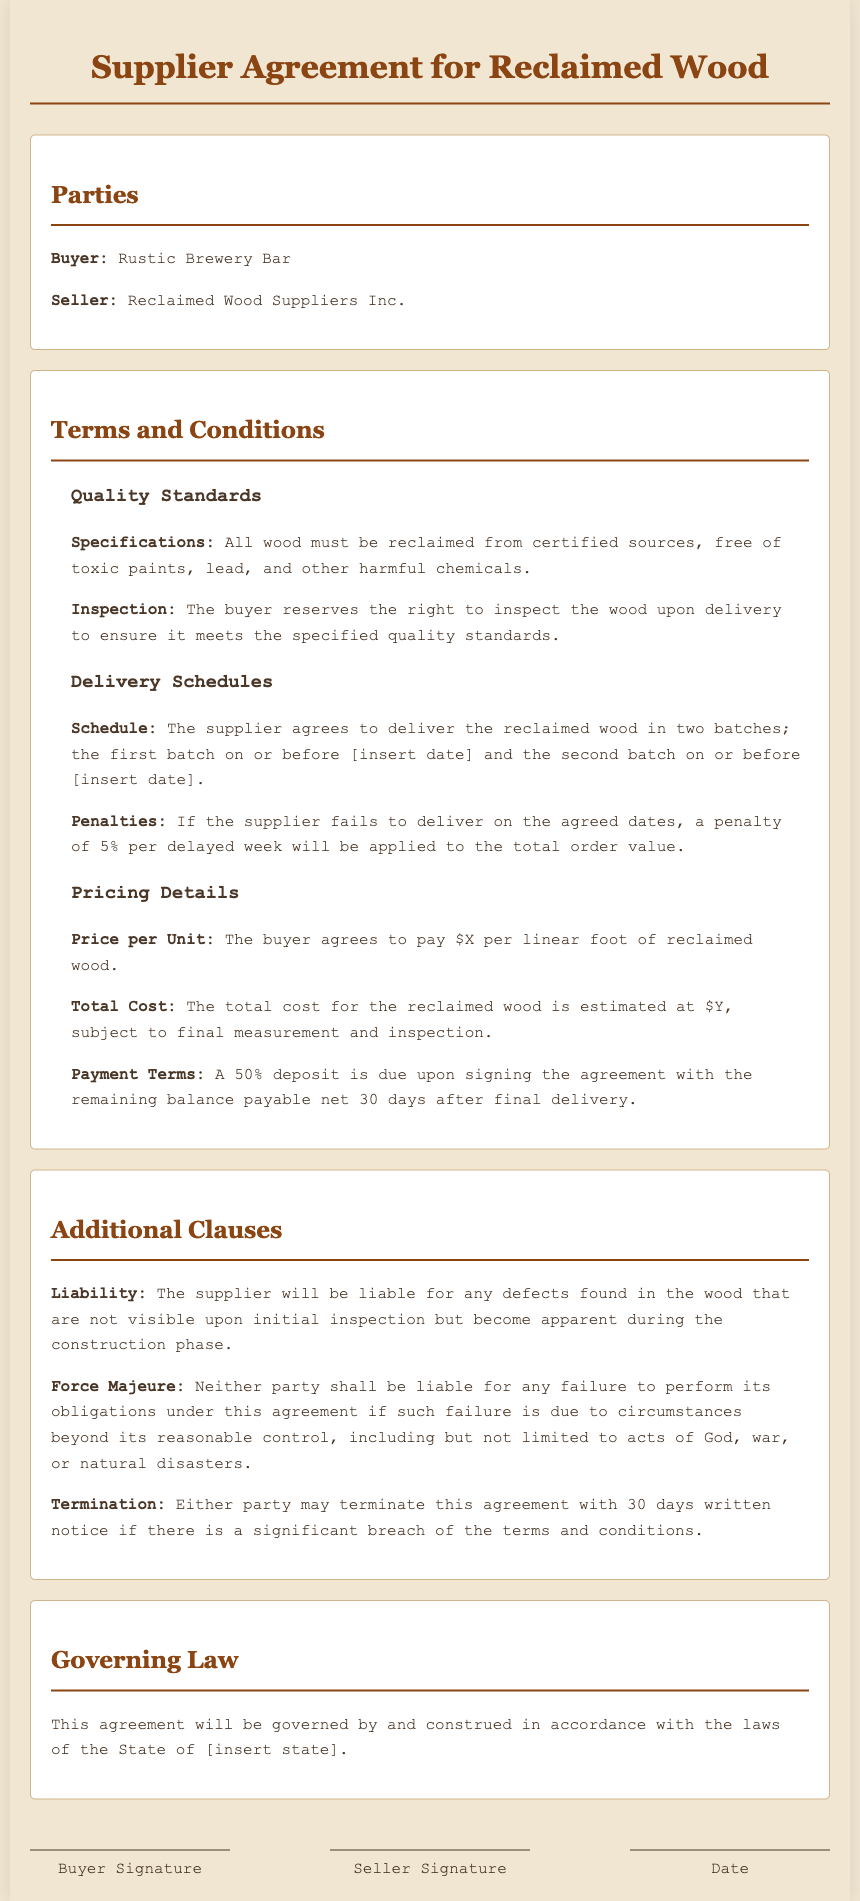What is the name of the buyer? The buyer's name is specified in the document under the Parties section as "Rustic Brewery Bar."
Answer: Rustic Brewery Bar What is the price per unit of reclaimed wood? The document states that the price per unit is defined under Pricing Details as "$X per linear foot."
Answer: $X per linear foot What penalty applies for late delivery? Under Delivery Schedules, it states that a penalty of 5% per delayed week will be applied if the supplier fails to deliver on time.
Answer: 5% How many batches will the wood be delivered in? The Delivery Schedules section mentions that the supplier agrees to deliver the wood in "two batches."
Answer: two batches What is the percentage of the deposit due upon signing? The document specifies under Payment Terms that a 50% deposit is due upon signing the agreement.
Answer: 50% What is the governing law of this agreement? The agreement states under Governing Law that it will be governed by the laws of a specific state, mentioned as "[insert state]."
Answer: [insert state] What are the conditions for liability regarding defects? The liability conditions are mentioned in the Additional Clauses section, stating that the supplier will be liable for any defects not visible upon initial inspection.
Answer: visible upon initial inspection What clause allows termination of the agreement? The document mentions in the Additional Clauses section that either party may terminate the agreement with "30 days written notice" if there is a significant breach.
Answer: 30 days written notice 